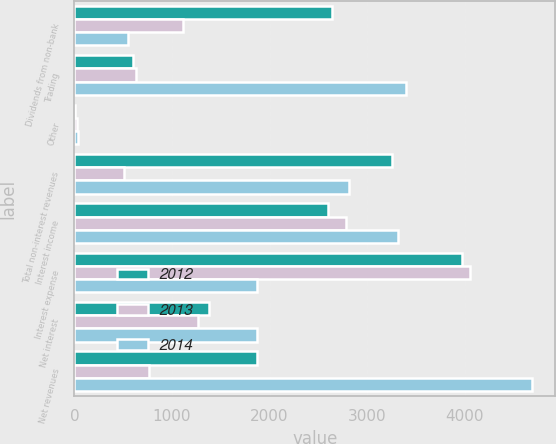Convert chart. <chart><loc_0><loc_0><loc_500><loc_500><stacked_bar_chart><ecel><fcel>Dividends from non-bank<fcel>Trading<fcel>Other<fcel>Total non-interest revenues<fcel>Interest income<fcel>Interest expense<fcel>Net interest<fcel>Net revenues<nl><fcel>2012<fcel>2641<fcel>601<fcel>10<fcel>3251<fcel>2594<fcel>3970<fcel>1376<fcel>1875<nl><fcel>2013<fcel>1113<fcel>635<fcel>27<fcel>505<fcel>2783<fcel>4053<fcel>1270<fcel>765<nl><fcel>2014<fcel>545<fcel>3400<fcel>36<fcel>2817<fcel>3316<fcel>1874<fcel>1874<fcel>4691<nl></chart> 